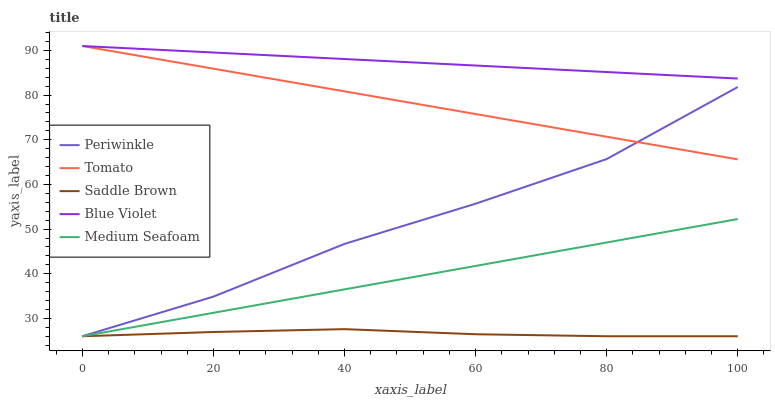Does Saddle Brown have the minimum area under the curve?
Answer yes or no. Yes. Does Blue Violet have the maximum area under the curve?
Answer yes or no. Yes. Does Periwinkle have the minimum area under the curve?
Answer yes or no. No. Does Periwinkle have the maximum area under the curve?
Answer yes or no. No. Is Medium Seafoam the smoothest?
Answer yes or no. Yes. Is Periwinkle the roughest?
Answer yes or no. Yes. Is Saddle Brown the smoothest?
Answer yes or no. No. Is Saddle Brown the roughest?
Answer yes or no. No. Does Periwinkle have the lowest value?
Answer yes or no. Yes. Does Blue Violet have the lowest value?
Answer yes or no. No. Does Blue Violet have the highest value?
Answer yes or no. Yes. Does Periwinkle have the highest value?
Answer yes or no. No. Is Periwinkle less than Blue Violet?
Answer yes or no. Yes. Is Blue Violet greater than Medium Seafoam?
Answer yes or no. Yes. Does Periwinkle intersect Saddle Brown?
Answer yes or no. Yes. Is Periwinkle less than Saddle Brown?
Answer yes or no. No. Is Periwinkle greater than Saddle Brown?
Answer yes or no. No. Does Periwinkle intersect Blue Violet?
Answer yes or no. No. 